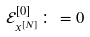<formula> <loc_0><loc_0><loc_500><loc_500>\mathcal { E } _ { x ^ { [ N ] } } ^ { [ 0 ] } \colon = 0</formula> 